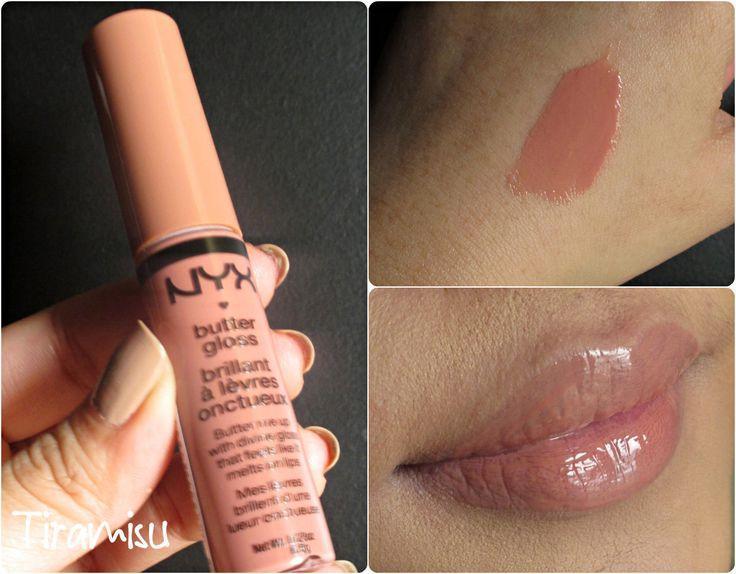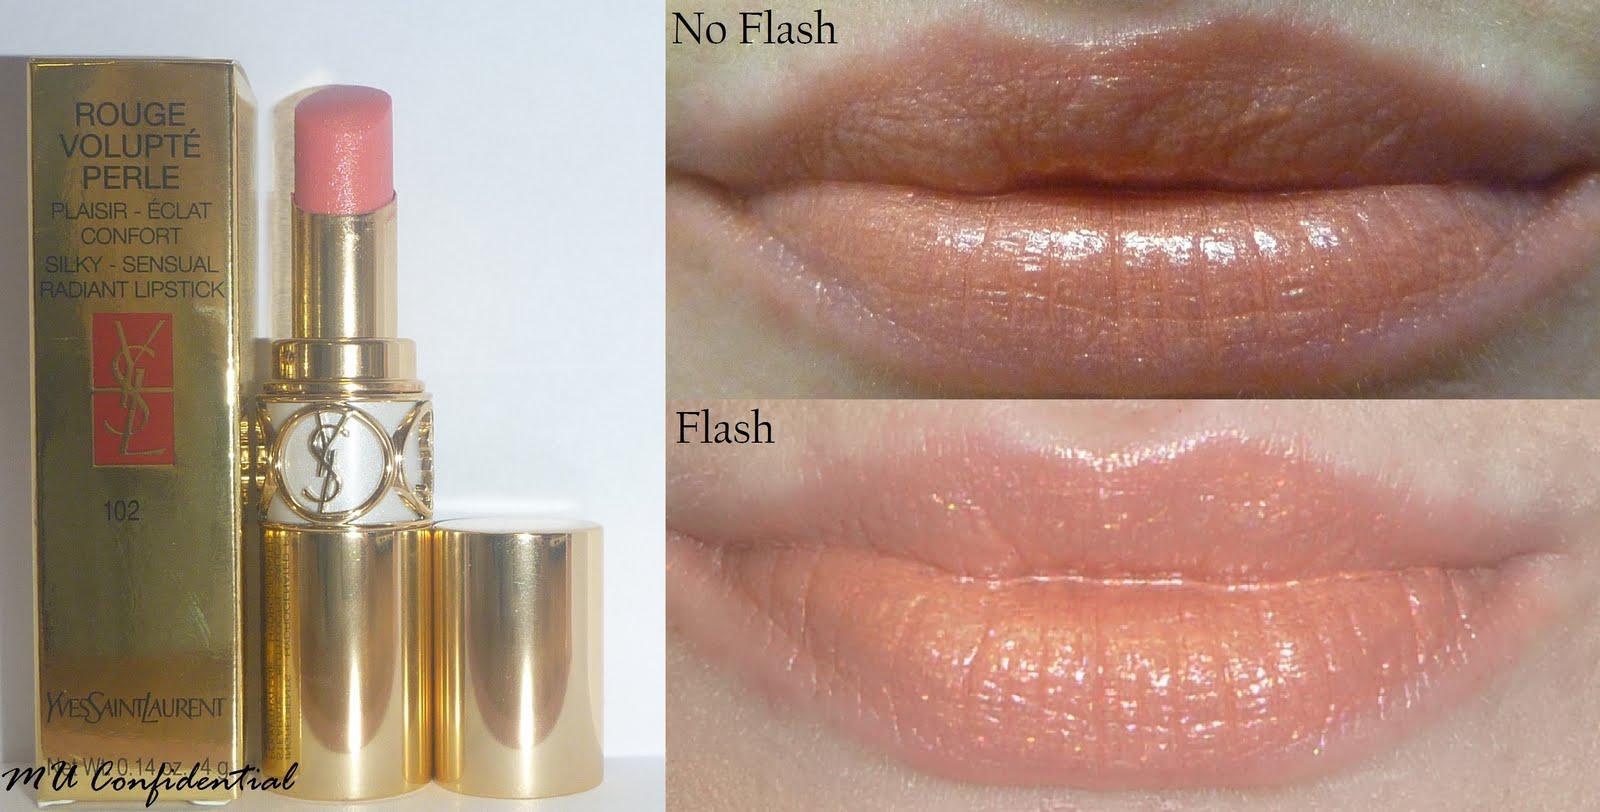The first image is the image on the left, the second image is the image on the right. Evaluate the accuracy of this statement regarding the images: "YSL Rouge Volupte #2 is featured.". Is it true? Answer yes or no. No. The first image is the image on the left, the second image is the image on the right. Evaluate the accuracy of this statement regarding the images: "Both images in the pair show lipstick shades displayed on lips.". Is it true? Answer yes or no. Yes. 